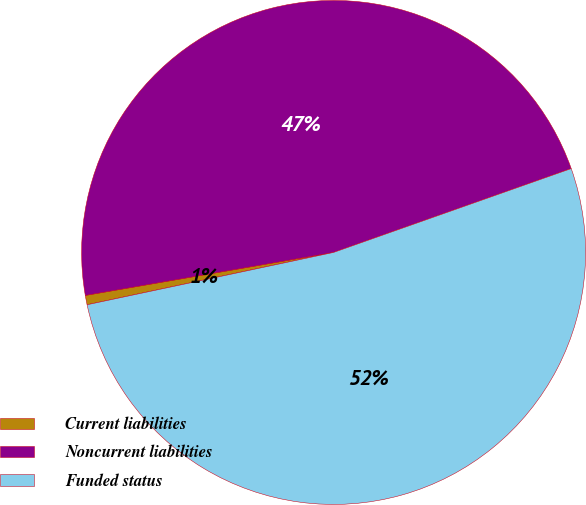Convert chart to OTSL. <chart><loc_0><loc_0><loc_500><loc_500><pie_chart><fcel>Current liabilities<fcel>Noncurrent liabilities<fcel>Funded status<nl><fcel>0.6%<fcel>47.33%<fcel>52.07%<nl></chart> 